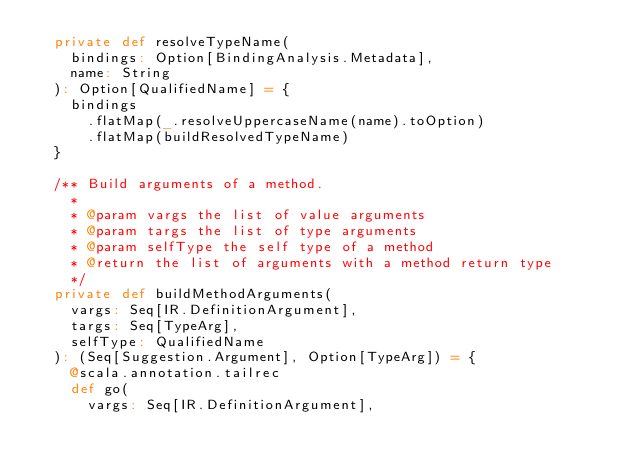Convert code to text. <code><loc_0><loc_0><loc_500><loc_500><_Scala_>  private def resolveTypeName(
    bindings: Option[BindingAnalysis.Metadata],
    name: String
  ): Option[QualifiedName] = {
    bindings
      .flatMap(_.resolveUppercaseName(name).toOption)
      .flatMap(buildResolvedTypeName)
  }

  /** Build arguments of a method.
    *
    * @param vargs the list of value arguments
    * @param targs the list of type arguments
    * @param selfType the self type of a method
    * @return the list of arguments with a method return type
    */
  private def buildMethodArguments(
    vargs: Seq[IR.DefinitionArgument],
    targs: Seq[TypeArg],
    selfType: QualifiedName
  ): (Seq[Suggestion.Argument], Option[TypeArg]) = {
    @scala.annotation.tailrec
    def go(
      vargs: Seq[IR.DefinitionArgument],</code> 